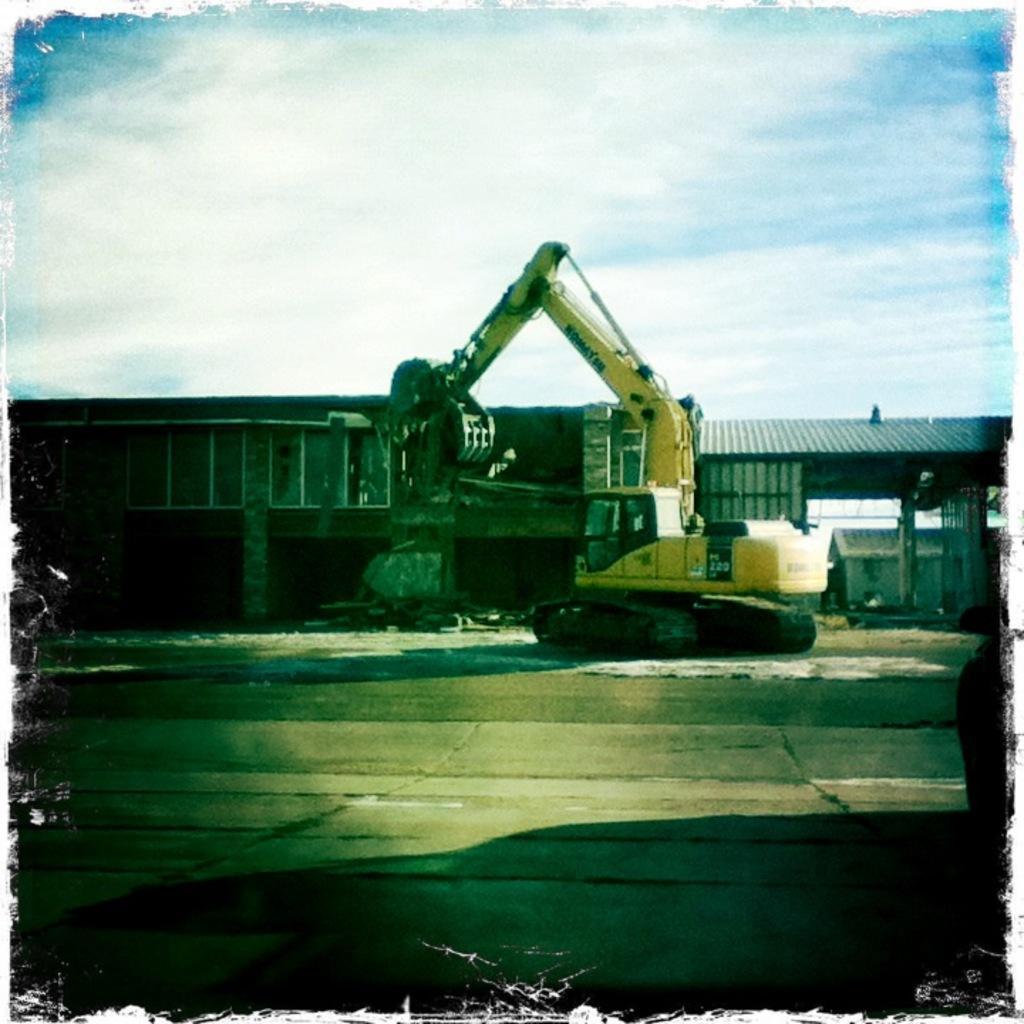In one or two sentences, can you explain what this image depicts? In this picture I can see a crane and few houses in the back and I can see a blue cloudy sky. 